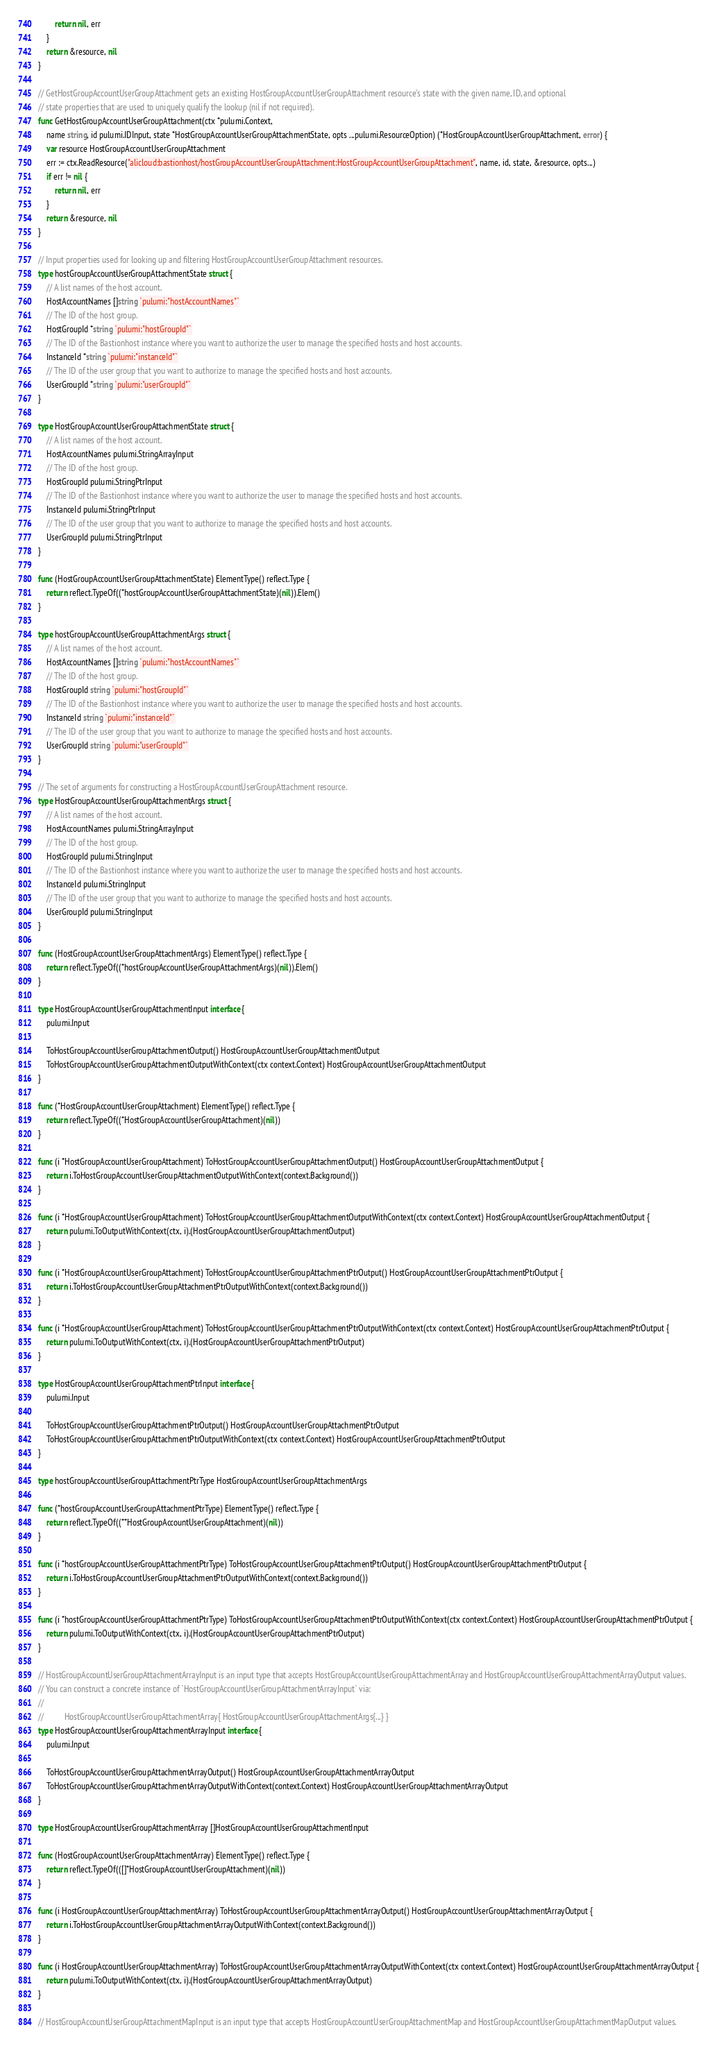Convert code to text. <code><loc_0><loc_0><loc_500><loc_500><_Go_>		return nil, err
	}
	return &resource, nil
}

// GetHostGroupAccountUserGroupAttachment gets an existing HostGroupAccountUserGroupAttachment resource's state with the given name, ID, and optional
// state properties that are used to uniquely qualify the lookup (nil if not required).
func GetHostGroupAccountUserGroupAttachment(ctx *pulumi.Context,
	name string, id pulumi.IDInput, state *HostGroupAccountUserGroupAttachmentState, opts ...pulumi.ResourceOption) (*HostGroupAccountUserGroupAttachment, error) {
	var resource HostGroupAccountUserGroupAttachment
	err := ctx.ReadResource("alicloud:bastionhost/hostGroupAccountUserGroupAttachment:HostGroupAccountUserGroupAttachment", name, id, state, &resource, opts...)
	if err != nil {
		return nil, err
	}
	return &resource, nil
}

// Input properties used for looking up and filtering HostGroupAccountUserGroupAttachment resources.
type hostGroupAccountUserGroupAttachmentState struct {
	// A list names of the host account.
	HostAccountNames []string `pulumi:"hostAccountNames"`
	// The ID of the host group.
	HostGroupId *string `pulumi:"hostGroupId"`
	// The ID of the Bastionhost instance where you want to authorize the user to manage the specified hosts and host accounts.
	InstanceId *string `pulumi:"instanceId"`
	// The ID of the user group that you want to authorize to manage the specified hosts and host accounts.
	UserGroupId *string `pulumi:"userGroupId"`
}

type HostGroupAccountUserGroupAttachmentState struct {
	// A list names of the host account.
	HostAccountNames pulumi.StringArrayInput
	// The ID of the host group.
	HostGroupId pulumi.StringPtrInput
	// The ID of the Bastionhost instance where you want to authorize the user to manage the specified hosts and host accounts.
	InstanceId pulumi.StringPtrInput
	// The ID of the user group that you want to authorize to manage the specified hosts and host accounts.
	UserGroupId pulumi.StringPtrInput
}

func (HostGroupAccountUserGroupAttachmentState) ElementType() reflect.Type {
	return reflect.TypeOf((*hostGroupAccountUserGroupAttachmentState)(nil)).Elem()
}

type hostGroupAccountUserGroupAttachmentArgs struct {
	// A list names of the host account.
	HostAccountNames []string `pulumi:"hostAccountNames"`
	// The ID of the host group.
	HostGroupId string `pulumi:"hostGroupId"`
	// The ID of the Bastionhost instance where you want to authorize the user to manage the specified hosts and host accounts.
	InstanceId string `pulumi:"instanceId"`
	// The ID of the user group that you want to authorize to manage the specified hosts and host accounts.
	UserGroupId string `pulumi:"userGroupId"`
}

// The set of arguments for constructing a HostGroupAccountUserGroupAttachment resource.
type HostGroupAccountUserGroupAttachmentArgs struct {
	// A list names of the host account.
	HostAccountNames pulumi.StringArrayInput
	// The ID of the host group.
	HostGroupId pulumi.StringInput
	// The ID of the Bastionhost instance where you want to authorize the user to manage the specified hosts and host accounts.
	InstanceId pulumi.StringInput
	// The ID of the user group that you want to authorize to manage the specified hosts and host accounts.
	UserGroupId pulumi.StringInput
}

func (HostGroupAccountUserGroupAttachmentArgs) ElementType() reflect.Type {
	return reflect.TypeOf((*hostGroupAccountUserGroupAttachmentArgs)(nil)).Elem()
}

type HostGroupAccountUserGroupAttachmentInput interface {
	pulumi.Input

	ToHostGroupAccountUserGroupAttachmentOutput() HostGroupAccountUserGroupAttachmentOutput
	ToHostGroupAccountUserGroupAttachmentOutputWithContext(ctx context.Context) HostGroupAccountUserGroupAttachmentOutput
}

func (*HostGroupAccountUserGroupAttachment) ElementType() reflect.Type {
	return reflect.TypeOf((*HostGroupAccountUserGroupAttachment)(nil))
}

func (i *HostGroupAccountUserGroupAttachment) ToHostGroupAccountUserGroupAttachmentOutput() HostGroupAccountUserGroupAttachmentOutput {
	return i.ToHostGroupAccountUserGroupAttachmentOutputWithContext(context.Background())
}

func (i *HostGroupAccountUserGroupAttachment) ToHostGroupAccountUserGroupAttachmentOutputWithContext(ctx context.Context) HostGroupAccountUserGroupAttachmentOutput {
	return pulumi.ToOutputWithContext(ctx, i).(HostGroupAccountUserGroupAttachmentOutput)
}

func (i *HostGroupAccountUserGroupAttachment) ToHostGroupAccountUserGroupAttachmentPtrOutput() HostGroupAccountUserGroupAttachmentPtrOutput {
	return i.ToHostGroupAccountUserGroupAttachmentPtrOutputWithContext(context.Background())
}

func (i *HostGroupAccountUserGroupAttachment) ToHostGroupAccountUserGroupAttachmentPtrOutputWithContext(ctx context.Context) HostGroupAccountUserGroupAttachmentPtrOutput {
	return pulumi.ToOutputWithContext(ctx, i).(HostGroupAccountUserGroupAttachmentPtrOutput)
}

type HostGroupAccountUserGroupAttachmentPtrInput interface {
	pulumi.Input

	ToHostGroupAccountUserGroupAttachmentPtrOutput() HostGroupAccountUserGroupAttachmentPtrOutput
	ToHostGroupAccountUserGroupAttachmentPtrOutputWithContext(ctx context.Context) HostGroupAccountUserGroupAttachmentPtrOutput
}

type hostGroupAccountUserGroupAttachmentPtrType HostGroupAccountUserGroupAttachmentArgs

func (*hostGroupAccountUserGroupAttachmentPtrType) ElementType() reflect.Type {
	return reflect.TypeOf((**HostGroupAccountUserGroupAttachment)(nil))
}

func (i *hostGroupAccountUserGroupAttachmentPtrType) ToHostGroupAccountUserGroupAttachmentPtrOutput() HostGroupAccountUserGroupAttachmentPtrOutput {
	return i.ToHostGroupAccountUserGroupAttachmentPtrOutputWithContext(context.Background())
}

func (i *hostGroupAccountUserGroupAttachmentPtrType) ToHostGroupAccountUserGroupAttachmentPtrOutputWithContext(ctx context.Context) HostGroupAccountUserGroupAttachmentPtrOutput {
	return pulumi.ToOutputWithContext(ctx, i).(HostGroupAccountUserGroupAttachmentPtrOutput)
}

// HostGroupAccountUserGroupAttachmentArrayInput is an input type that accepts HostGroupAccountUserGroupAttachmentArray and HostGroupAccountUserGroupAttachmentArrayOutput values.
// You can construct a concrete instance of `HostGroupAccountUserGroupAttachmentArrayInput` via:
//
//          HostGroupAccountUserGroupAttachmentArray{ HostGroupAccountUserGroupAttachmentArgs{...} }
type HostGroupAccountUserGroupAttachmentArrayInput interface {
	pulumi.Input

	ToHostGroupAccountUserGroupAttachmentArrayOutput() HostGroupAccountUserGroupAttachmentArrayOutput
	ToHostGroupAccountUserGroupAttachmentArrayOutputWithContext(context.Context) HostGroupAccountUserGroupAttachmentArrayOutput
}

type HostGroupAccountUserGroupAttachmentArray []HostGroupAccountUserGroupAttachmentInput

func (HostGroupAccountUserGroupAttachmentArray) ElementType() reflect.Type {
	return reflect.TypeOf(([]*HostGroupAccountUserGroupAttachment)(nil))
}

func (i HostGroupAccountUserGroupAttachmentArray) ToHostGroupAccountUserGroupAttachmentArrayOutput() HostGroupAccountUserGroupAttachmentArrayOutput {
	return i.ToHostGroupAccountUserGroupAttachmentArrayOutputWithContext(context.Background())
}

func (i HostGroupAccountUserGroupAttachmentArray) ToHostGroupAccountUserGroupAttachmentArrayOutputWithContext(ctx context.Context) HostGroupAccountUserGroupAttachmentArrayOutput {
	return pulumi.ToOutputWithContext(ctx, i).(HostGroupAccountUserGroupAttachmentArrayOutput)
}

// HostGroupAccountUserGroupAttachmentMapInput is an input type that accepts HostGroupAccountUserGroupAttachmentMap and HostGroupAccountUserGroupAttachmentMapOutput values.</code> 